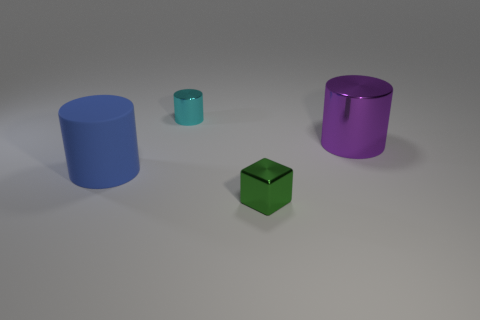There is a small thing left of the metal thing that is in front of the large blue rubber thing; is there a tiny cyan metal cylinder on the left side of it? Upon examining the image, the described small item to the left of the metal object in front of the large blue rubber-like cylinder does not appear to be a tiny cyan metal cylinder. Instead, it's a small teal-colored item resembling a container cap, and there's no cylinder directly on its left side. 